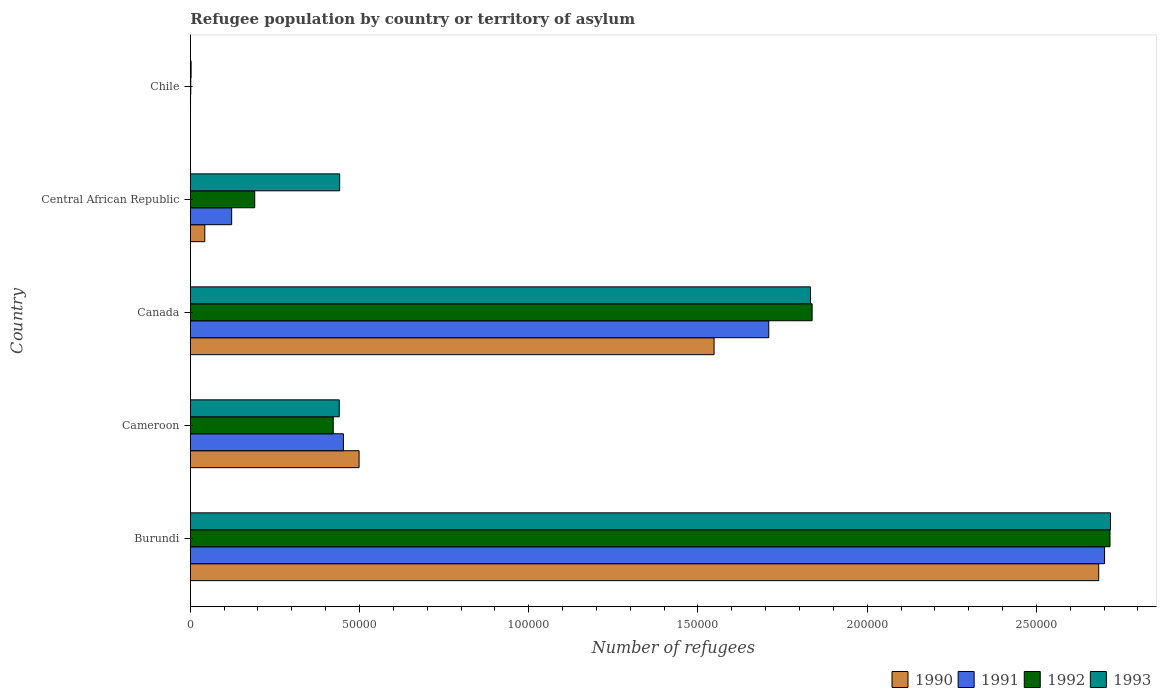How many groups of bars are there?
Give a very brief answer. 5. How many bars are there on the 4th tick from the bottom?
Your answer should be very brief. 4. What is the label of the 5th group of bars from the top?
Provide a short and direct response. Burundi. In how many cases, is the number of bars for a given country not equal to the number of legend labels?
Provide a succinct answer. 0. What is the number of refugees in 1993 in Burundi?
Provide a succinct answer. 2.72e+05. Across all countries, what is the maximum number of refugees in 1991?
Give a very brief answer. 2.70e+05. Across all countries, what is the minimum number of refugees in 1991?
Offer a terse response. 72. In which country was the number of refugees in 1993 maximum?
Provide a short and direct response. Burundi. In which country was the number of refugees in 1992 minimum?
Offer a terse response. Chile. What is the total number of refugees in 1991 in the graph?
Offer a very short reply. 4.99e+05. What is the difference between the number of refugees in 1990 in Cameroon and that in Canada?
Provide a short and direct response. -1.05e+05. What is the difference between the number of refugees in 1991 in Cameroon and the number of refugees in 1990 in Canada?
Offer a terse response. -1.10e+05. What is the average number of refugees in 1990 per country?
Offer a very short reply. 9.55e+04. What is the difference between the number of refugees in 1992 and number of refugees in 1991 in Central African Republic?
Your response must be concise. 6817. What is the ratio of the number of refugees in 1991 in Canada to that in Central African Republic?
Give a very brief answer. 13.98. What is the difference between the highest and the second highest number of refugees in 1991?
Offer a very short reply. 9.92e+04. What is the difference between the highest and the lowest number of refugees in 1991?
Provide a succinct answer. 2.70e+05. What does the 2nd bar from the top in Cameroon represents?
Your answer should be very brief. 1992. Is it the case that in every country, the sum of the number of refugees in 1991 and number of refugees in 1992 is greater than the number of refugees in 1993?
Your response must be concise. No. What is the difference between two consecutive major ticks on the X-axis?
Offer a terse response. 5.00e+04. Does the graph contain any zero values?
Your response must be concise. No. Where does the legend appear in the graph?
Offer a very short reply. Bottom right. How are the legend labels stacked?
Your answer should be very brief. Horizontal. What is the title of the graph?
Offer a very short reply. Refugee population by country or territory of asylum. Does "1961" appear as one of the legend labels in the graph?
Ensure brevity in your answer.  No. What is the label or title of the X-axis?
Provide a succinct answer. Number of refugees. What is the Number of refugees of 1990 in Burundi?
Ensure brevity in your answer.  2.68e+05. What is the Number of refugees of 1991 in Burundi?
Ensure brevity in your answer.  2.70e+05. What is the Number of refugees in 1992 in Burundi?
Your answer should be compact. 2.72e+05. What is the Number of refugees in 1993 in Burundi?
Offer a terse response. 2.72e+05. What is the Number of refugees in 1990 in Cameroon?
Provide a short and direct response. 4.99e+04. What is the Number of refugees in 1991 in Cameroon?
Offer a terse response. 4.52e+04. What is the Number of refugees in 1992 in Cameroon?
Ensure brevity in your answer.  4.22e+04. What is the Number of refugees in 1993 in Cameroon?
Give a very brief answer. 4.40e+04. What is the Number of refugees of 1990 in Canada?
Offer a terse response. 1.55e+05. What is the Number of refugees of 1991 in Canada?
Make the answer very short. 1.71e+05. What is the Number of refugees in 1992 in Canada?
Your answer should be compact. 1.84e+05. What is the Number of refugees of 1993 in Canada?
Your answer should be compact. 1.83e+05. What is the Number of refugees in 1990 in Central African Republic?
Give a very brief answer. 4284. What is the Number of refugees in 1991 in Central African Republic?
Offer a very short reply. 1.22e+04. What is the Number of refugees of 1992 in Central African Republic?
Your answer should be very brief. 1.90e+04. What is the Number of refugees of 1993 in Central African Republic?
Your answer should be very brief. 4.41e+04. What is the Number of refugees of 1992 in Chile?
Offer a very short reply. 142. What is the Number of refugees in 1993 in Chile?
Your answer should be compact. 239. Across all countries, what is the maximum Number of refugees in 1990?
Make the answer very short. 2.68e+05. Across all countries, what is the maximum Number of refugees in 1991?
Provide a short and direct response. 2.70e+05. Across all countries, what is the maximum Number of refugees of 1992?
Your answer should be very brief. 2.72e+05. Across all countries, what is the maximum Number of refugees in 1993?
Ensure brevity in your answer.  2.72e+05. Across all countries, what is the minimum Number of refugees in 1990?
Ensure brevity in your answer.  58. Across all countries, what is the minimum Number of refugees in 1991?
Your answer should be very brief. 72. Across all countries, what is the minimum Number of refugees of 1992?
Your response must be concise. 142. Across all countries, what is the minimum Number of refugees of 1993?
Your answer should be compact. 239. What is the total Number of refugees in 1990 in the graph?
Give a very brief answer. 4.77e+05. What is the total Number of refugees of 1991 in the graph?
Your response must be concise. 4.99e+05. What is the total Number of refugees of 1992 in the graph?
Make the answer very short. 5.17e+05. What is the total Number of refugees in 1993 in the graph?
Offer a terse response. 5.44e+05. What is the difference between the Number of refugees in 1990 in Burundi and that in Cameroon?
Ensure brevity in your answer.  2.19e+05. What is the difference between the Number of refugees in 1991 in Burundi and that in Cameroon?
Ensure brevity in your answer.  2.25e+05. What is the difference between the Number of refugees in 1992 in Burundi and that in Cameroon?
Offer a very short reply. 2.30e+05. What is the difference between the Number of refugees in 1993 in Burundi and that in Cameroon?
Offer a very short reply. 2.28e+05. What is the difference between the Number of refugees of 1990 in Burundi and that in Canada?
Your response must be concise. 1.14e+05. What is the difference between the Number of refugees in 1991 in Burundi and that in Canada?
Provide a short and direct response. 9.92e+04. What is the difference between the Number of refugees in 1992 in Burundi and that in Canada?
Offer a very short reply. 8.80e+04. What is the difference between the Number of refugees of 1993 in Burundi and that in Canada?
Your answer should be very brief. 8.86e+04. What is the difference between the Number of refugees in 1990 in Burundi and that in Central African Republic?
Provide a succinct answer. 2.64e+05. What is the difference between the Number of refugees of 1991 in Burundi and that in Central African Republic?
Your response must be concise. 2.58e+05. What is the difference between the Number of refugees of 1992 in Burundi and that in Central African Republic?
Your answer should be very brief. 2.53e+05. What is the difference between the Number of refugees of 1993 in Burundi and that in Central African Republic?
Keep it short and to the point. 2.28e+05. What is the difference between the Number of refugees of 1990 in Burundi and that in Chile?
Offer a terse response. 2.68e+05. What is the difference between the Number of refugees in 1991 in Burundi and that in Chile?
Provide a short and direct response. 2.70e+05. What is the difference between the Number of refugees in 1992 in Burundi and that in Chile?
Provide a succinct answer. 2.72e+05. What is the difference between the Number of refugees of 1993 in Burundi and that in Chile?
Give a very brief answer. 2.72e+05. What is the difference between the Number of refugees of 1990 in Cameroon and that in Canada?
Keep it short and to the point. -1.05e+05. What is the difference between the Number of refugees in 1991 in Cameroon and that in Canada?
Provide a short and direct response. -1.26e+05. What is the difference between the Number of refugees of 1992 in Cameroon and that in Canada?
Provide a succinct answer. -1.41e+05. What is the difference between the Number of refugees in 1993 in Cameroon and that in Canada?
Ensure brevity in your answer.  -1.39e+05. What is the difference between the Number of refugees of 1990 in Cameroon and that in Central African Republic?
Your answer should be very brief. 4.56e+04. What is the difference between the Number of refugees in 1991 in Cameroon and that in Central African Republic?
Your answer should be compact. 3.30e+04. What is the difference between the Number of refugees in 1992 in Cameroon and that in Central African Republic?
Provide a short and direct response. 2.32e+04. What is the difference between the Number of refugees of 1993 in Cameroon and that in Central African Republic?
Make the answer very short. -116. What is the difference between the Number of refugees of 1990 in Cameroon and that in Chile?
Your response must be concise. 4.98e+04. What is the difference between the Number of refugees of 1991 in Cameroon and that in Chile?
Your answer should be very brief. 4.52e+04. What is the difference between the Number of refugees in 1992 in Cameroon and that in Chile?
Keep it short and to the point. 4.21e+04. What is the difference between the Number of refugees of 1993 in Cameroon and that in Chile?
Your answer should be compact. 4.38e+04. What is the difference between the Number of refugees of 1990 in Canada and that in Central African Republic?
Offer a very short reply. 1.50e+05. What is the difference between the Number of refugees in 1991 in Canada and that in Central African Republic?
Make the answer very short. 1.59e+05. What is the difference between the Number of refugees in 1992 in Canada and that in Central African Republic?
Give a very brief answer. 1.65e+05. What is the difference between the Number of refugees in 1993 in Canada and that in Central African Republic?
Make the answer very short. 1.39e+05. What is the difference between the Number of refugees of 1990 in Canada and that in Chile?
Your answer should be very brief. 1.55e+05. What is the difference between the Number of refugees of 1991 in Canada and that in Chile?
Your response must be concise. 1.71e+05. What is the difference between the Number of refugees in 1992 in Canada and that in Chile?
Offer a very short reply. 1.84e+05. What is the difference between the Number of refugees in 1993 in Canada and that in Chile?
Your answer should be very brief. 1.83e+05. What is the difference between the Number of refugees of 1990 in Central African Republic and that in Chile?
Your answer should be very brief. 4226. What is the difference between the Number of refugees in 1991 in Central African Republic and that in Chile?
Offer a very short reply. 1.22e+04. What is the difference between the Number of refugees of 1992 in Central African Republic and that in Chile?
Give a very brief answer. 1.89e+04. What is the difference between the Number of refugees in 1993 in Central African Republic and that in Chile?
Ensure brevity in your answer.  4.39e+04. What is the difference between the Number of refugees of 1990 in Burundi and the Number of refugees of 1991 in Cameroon?
Ensure brevity in your answer.  2.23e+05. What is the difference between the Number of refugees of 1990 in Burundi and the Number of refugees of 1992 in Cameroon?
Offer a very short reply. 2.26e+05. What is the difference between the Number of refugees of 1990 in Burundi and the Number of refugees of 1993 in Cameroon?
Your answer should be very brief. 2.24e+05. What is the difference between the Number of refugees of 1991 in Burundi and the Number of refugees of 1992 in Cameroon?
Make the answer very short. 2.28e+05. What is the difference between the Number of refugees of 1991 in Burundi and the Number of refugees of 1993 in Cameroon?
Offer a terse response. 2.26e+05. What is the difference between the Number of refugees of 1992 in Burundi and the Number of refugees of 1993 in Cameroon?
Offer a very short reply. 2.28e+05. What is the difference between the Number of refugees in 1990 in Burundi and the Number of refugees in 1991 in Canada?
Offer a very short reply. 9.75e+04. What is the difference between the Number of refugees in 1990 in Burundi and the Number of refugees in 1992 in Canada?
Provide a succinct answer. 8.47e+04. What is the difference between the Number of refugees of 1990 in Burundi and the Number of refugees of 1993 in Canada?
Keep it short and to the point. 8.52e+04. What is the difference between the Number of refugees in 1991 in Burundi and the Number of refugees in 1992 in Canada?
Your answer should be compact. 8.64e+04. What is the difference between the Number of refugees in 1991 in Burundi and the Number of refugees in 1993 in Canada?
Offer a terse response. 8.69e+04. What is the difference between the Number of refugees in 1992 in Burundi and the Number of refugees in 1993 in Canada?
Keep it short and to the point. 8.85e+04. What is the difference between the Number of refugees in 1990 in Burundi and the Number of refugees in 1991 in Central African Republic?
Your answer should be very brief. 2.56e+05. What is the difference between the Number of refugees of 1990 in Burundi and the Number of refugees of 1992 in Central African Republic?
Your answer should be compact. 2.49e+05. What is the difference between the Number of refugees in 1990 in Burundi and the Number of refugees in 1993 in Central African Republic?
Offer a very short reply. 2.24e+05. What is the difference between the Number of refugees of 1991 in Burundi and the Number of refugees of 1992 in Central African Republic?
Make the answer very short. 2.51e+05. What is the difference between the Number of refugees in 1991 in Burundi and the Number of refugees in 1993 in Central African Republic?
Provide a short and direct response. 2.26e+05. What is the difference between the Number of refugees of 1992 in Burundi and the Number of refugees of 1993 in Central African Republic?
Your answer should be compact. 2.28e+05. What is the difference between the Number of refugees of 1990 in Burundi and the Number of refugees of 1991 in Chile?
Offer a very short reply. 2.68e+05. What is the difference between the Number of refugees in 1990 in Burundi and the Number of refugees in 1992 in Chile?
Make the answer very short. 2.68e+05. What is the difference between the Number of refugees in 1990 in Burundi and the Number of refugees in 1993 in Chile?
Your answer should be very brief. 2.68e+05. What is the difference between the Number of refugees in 1991 in Burundi and the Number of refugees in 1992 in Chile?
Ensure brevity in your answer.  2.70e+05. What is the difference between the Number of refugees in 1991 in Burundi and the Number of refugees in 1993 in Chile?
Make the answer very short. 2.70e+05. What is the difference between the Number of refugees of 1992 in Burundi and the Number of refugees of 1993 in Chile?
Make the answer very short. 2.72e+05. What is the difference between the Number of refugees in 1990 in Cameroon and the Number of refugees in 1991 in Canada?
Make the answer very short. -1.21e+05. What is the difference between the Number of refugees in 1990 in Cameroon and the Number of refugees in 1992 in Canada?
Provide a short and direct response. -1.34e+05. What is the difference between the Number of refugees in 1990 in Cameroon and the Number of refugees in 1993 in Canada?
Offer a terse response. -1.33e+05. What is the difference between the Number of refugees in 1991 in Cameroon and the Number of refugees in 1992 in Canada?
Your response must be concise. -1.38e+05. What is the difference between the Number of refugees of 1991 in Cameroon and the Number of refugees of 1993 in Canada?
Provide a short and direct response. -1.38e+05. What is the difference between the Number of refugees of 1992 in Cameroon and the Number of refugees of 1993 in Canada?
Ensure brevity in your answer.  -1.41e+05. What is the difference between the Number of refugees in 1990 in Cameroon and the Number of refugees in 1991 in Central African Republic?
Your response must be concise. 3.77e+04. What is the difference between the Number of refugees in 1990 in Cameroon and the Number of refugees in 1992 in Central African Republic?
Make the answer very short. 3.08e+04. What is the difference between the Number of refugees of 1990 in Cameroon and the Number of refugees of 1993 in Central African Republic?
Provide a short and direct response. 5747. What is the difference between the Number of refugees in 1991 in Cameroon and the Number of refugees in 1992 in Central African Republic?
Your answer should be compact. 2.62e+04. What is the difference between the Number of refugees in 1991 in Cameroon and the Number of refugees in 1993 in Central African Republic?
Your answer should be compact. 1108. What is the difference between the Number of refugees of 1992 in Cameroon and the Number of refugees of 1993 in Central African Republic?
Your response must be concise. -1896. What is the difference between the Number of refugees of 1990 in Cameroon and the Number of refugees of 1991 in Chile?
Offer a very short reply. 4.98e+04. What is the difference between the Number of refugees of 1990 in Cameroon and the Number of refugees of 1992 in Chile?
Your response must be concise. 4.97e+04. What is the difference between the Number of refugees in 1990 in Cameroon and the Number of refugees in 1993 in Chile?
Offer a very short reply. 4.96e+04. What is the difference between the Number of refugees of 1991 in Cameroon and the Number of refugees of 1992 in Chile?
Offer a terse response. 4.51e+04. What is the difference between the Number of refugees of 1991 in Cameroon and the Number of refugees of 1993 in Chile?
Keep it short and to the point. 4.50e+04. What is the difference between the Number of refugees in 1992 in Cameroon and the Number of refugees in 1993 in Chile?
Offer a very short reply. 4.20e+04. What is the difference between the Number of refugees in 1990 in Canada and the Number of refugees in 1991 in Central African Republic?
Offer a very short reply. 1.43e+05. What is the difference between the Number of refugees in 1990 in Canada and the Number of refugees in 1992 in Central African Republic?
Provide a short and direct response. 1.36e+05. What is the difference between the Number of refugees in 1990 in Canada and the Number of refugees in 1993 in Central African Republic?
Give a very brief answer. 1.11e+05. What is the difference between the Number of refugees of 1991 in Canada and the Number of refugees of 1992 in Central African Republic?
Ensure brevity in your answer.  1.52e+05. What is the difference between the Number of refugees in 1991 in Canada and the Number of refugees in 1993 in Central African Republic?
Your answer should be very brief. 1.27e+05. What is the difference between the Number of refugees of 1992 in Canada and the Number of refugees of 1993 in Central African Republic?
Keep it short and to the point. 1.40e+05. What is the difference between the Number of refugees of 1990 in Canada and the Number of refugees of 1991 in Chile?
Offer a very short reply. 1.55e+05. What is the difference between the Number of refugees in 1990 in Canada and the Number of refugees in 1992 in Chile?
Give a very brief answer. 1.55e+05. What is the difference between the Number of refugees in 1990 in Canada and the Number of refugees in 1993 in Chile?
Your answer should be compact. 1.55e+05. What is the difference between the Number of refugees of 1991 in Canada and the Number of refugees of 1992 in Chile?
Offer a terse response. 1.71e+05. What is the difference between the Number of refugees in 1991 in Canada and the Number of refugees in 1993 in Chile?
Give a very brief answer. 1.71e+05. What is the difference between the Number of refugees in 1992 in Canada and the Number of refugees in 1993 in Chile?
Your response must be concise. 1.83e+05. What is the difference between the Number of refugees in 1990 in Central African Republic and the Number of refugees in 1991 in Chile?
Provide a short and direct response. 4212. What is the difference between the Number of refugees of 1990 in Central African Republic and the Number of refugees of 1992 in Chile?
Ensure brevity in your answer.  4142. What is the difference between the Number of refugees of 1990 in Central African Republic and the Number of refugees of 1993 in Chile?
Your answer should be compact. 4045. What is the difference between the Number of refugees in 1991 in Central African Republic and the Number of refugees in 1992 in Chile?
Your answer should be very brief. 1.21e+04. What is the difference between the Number of refugees in 1991 in Central African Republic and the Number of refugees in 1993 in Chile?
Provide a short and direct response. 1.20e+04. What is the difference between the Number of refugees in 1992 in Central African Republic and the Number of refugees in 1993 in Chile?
Provide a succinct answer. 1.88e+04. What is the average Number of refugees in 1990 per country?
Offer a terse response. 9.55e+04. What is the average Number of refugees of 1991 per country?
Your response must be concise. 9.97e+04. What is the average Number of refugees of 1992 per country?
Make the answer very short. 1.03e+05. What is the average Number of refugees of 1993 per country?
Your response must be concise. 1.09e+05. What is the difference between the Number of refugees of 1990 and Number of refugees of 1991 in Burundi?
Provide a succinct answer. -1733. What is the difference between the Number of refugees in 1990 and Number of refugees in 1992 in Burundi?
Give a very brief answer. -3342. What is the difference between the Number of refugees of 1990 and Number of refugees of 1993 in Burundi?
Provide a succinct answer. -3480. What is the difference between the Number of refugees in 1991 and Number of refugees in 1992 in Burundi?
Provide a succinct answer. -1609. What is the difference between the Number of refugees of 1991 and Number of refugees of 1993 in Burundi?
Your answer should be compact. -1747. What is the difference between the Number of refugees of 1992 and Number of refugees of 1993 in Burundi?
Provide a short and direct response. -138. What is the difference between the Number of refugees of 1990 and Number of refugees of 1991 in Cameroon?
Make the answer very short. 4639. What is the difference between the Number of refugees of 1990 and Number of refugees of 1992 in Cameroon?
Your answer should be very brief. 7643. What is the difference between the Number of refugees in 1990 and Number of refugees in 1993 in Cameroon?
Offer a terse response. 5863. What is the difference between the Number of refugees of 1991 and Number of refugees of 1992 in Cameroon?
Your answer should be very brief. 3004. What is the difference between the Number of refugees in 1991 and Number of refugees in 1993 in Cameroon?
Offer a terse response. 1224. What is the difference between the Number of refugees in 1992 and Number of refugees in 1993 in Cameroon?
Offer a very short reply. -1780. What is the difference between the Number of refugees of 1990 and Number of refugees of 1991 in Canada?
Provide a short and direct response. -1.62e+04. What is the difference between the Number of refugees of 1990 and Number of refugees of 1992 in Canada?
Keep it short and to the point. -2.90e+04. What is the difference between the Number of refugees of 1990 and Number of refugees of 1993 in Canada?
Your response must be concise. -2.85e+04. What is the difference between the Number of refugees in 1991 and Number of refugees in 1992 in Canada?
Your answer should be very brief. -1.28e+04. What is the difference between the Number of refugees of 1991 and Number of refugees of 1993 in Canada?
Offer a terse response. -1.23e+04. What is the difference between the Number of refugees in 1992 and Number of refugees in 1993 in Canada?
Offer a very short reply. 482. What is the difference between the Number of refugees of 1990 and Number of refugees of 1991 in Central African Republic?
Give a very brief answer. -7939. What is the difference between the Number of refugees of 1990 and Number of refugees of 1992 in Central African Republic?
Make the answer very short. -1.48e+04. What is the difference between the Number of refugees in 1990 and Number of refugees in 1993 in Central African Republic?
Provide a succinct answer. -3.98e+04. What is the difference between the Number of refugees in 1991 and Number of refugees in 1992 in Central African Republic?
Keep it short and to the point. -6817. What is the difference between the Number of refugees in 1991 and Number of refugees in 1993 in Central African Republic?
Give a very brief answer. -3.19e+04. What is the difference between the Number of refugees of 1992 and Number of refugees of 1993 in Central African Republic?
Make the answer very short. -2.51e+04. What is the difference between the Number of refugees of 1990 and Number of refugees of 1991 in Chile?
Keep it short and to the point. -14. What is the difference between the Number of refugees in 1990 and Number of refugees in 1992 in Chile?
Keep it short and to the point. -84. What is the difference between the Number of refugees of 1990 and Number of refugees of 1993 in Chile?
Offer a very short reply. -181. What is the difference between the Number of refugees of 1991 and Number of refugees of 1992 in Chile?
Offer a very short reply. -70. What is the difference between the Number of refugees of 1991 and Number of refugees of 1993 in Chile?
Provide a succinct answer. -167. What is the difference between the Number of refugees in 1992 and Number of refugees in 1993 in Chile?
Offer a terse response. -97. What is the ratio of the Number of refugees of 1990 in Burundi to that in Cameroon?
Make the answer very short. 5.38. What is the ratio of the Number of refugees of 1991 in Burundi to that in Cameroon?
Your answer should be compact. 5.97. What is the ratio of the Number of refugees of 1992 in Burundi to that in Cameroon?
Offer a terse response. 6.43. What is the ratio of the Number of refugees of 1993 in Burundi to that in Cameroon?
Keep it short and to the point. 6.18. What is the ratio of the Number of refugees of 1990 in Burundi to that in Canada?
Offer a terse response. 1.73. What is the ratio of the Number of refugees in 1991 in Burundi to that in Canada?
Provide a succinct answer. 1.58. What is the ratio of the Number of refugees in 1992 in Burundi to that in Canada?
Provide a succinct answer. 1.48. What is the ratio of the Number of refugees in 1993 in Burundi to that in Canada?
Provide a short and direct response. 1.48. What is the ratio of the Number of refugees of 1990 in Burundi to that in Central African Republic?
Ensure brevity in your answer.  62.65. What is the ratio of the Number of refugees of 1991 in Burundi to that in Central African Republic?
Provide a short and direct response. 22.1. What is the ratio of the Number of refugees of 1992 in Burundi to that in Central African Republic?
Your answer should be compact. 14.27. What is the ratio of the Number of refugees in 1993 in Burundi to that in Central African Republic?
Offer a terse response. 6.16. What is the ratio of the Number of refugees in 1990 in Burundi to that in Chile?
Your response must be concise. 4627.64. What is the ratio of the Number of refugees of 1991 in Burundi to that in Chile?
Offer a very short reply. 3751.89. What is the ratio of the Number of refugees of 1992 in Burundi to that in Chile?
Your response must be concise. 1913.7. What is the ratio of the Number of refugees of 1993 in Burundi to that in Chile?
Provide a short and direct response. 1137.59. What is the ratio of the Number of refugees in 1990 in Cameroon to that in Canada?
Your response must be concise. 0.32. What is the ratio of the Number of refugees of 1991 in Cameroon to that in Canada?
Offer a terse response. 0.26. What is the ratio of the Number of refugees in 1992 in Cameroon to that in Canada?
Make the answer very short. 0.23. What is the ratio of the Number of refugees of 1993 in Cameroon to that in Canada?
Offer a very short reply. 0.24. What is the ratio of the Number of refugees in 1990 in Cameroon to that in Central African Republic?
Your response must be concise. 11.64. What is the ratio of the Number of refugees in 1991 in Cameroon to that in Central African Republic?
Your response must be concise. 3.7. What is the ratio of the Number of refugees in 1992 in Cameroon to that in Central African Republic?
Your response must be concise. 2.22. What is the ratio of the Number of refugees of 1990 in Cameroon to that in Chile?
Your answer should be compact. 859.93. What is the ratio of the Number of refugees of 1991 in Cameroon to that in Chile?
Offer a terse response. 628.29. What is the ratio of the Number of refugees in 1992 in Cameroon to that in Chile?
Keep it short and to the point. 297.42. What is the ratio of the Number of refugees of 1993 in Cameroon to that in Chile?
Give a very brief answer. 184.15. What is the ratio of the Number of refugees of 1990 in Canada to that in Central African Republic?
Provide a succinct answer. 36.13. What is the ratio of the Number of refugees in 1991 in Canada to that in Central African Republic?
Offer a terse response. 13.98. What is the ratio of the Number of refugees of 1992 in Canada to that in Central African Republic?
Your answer should be compact. 9.65. What is the ratio of the Number of refugees of 1993 in Canada to that in Central African Republic?
Make the answer very short. 4.15. What is the ratio of the Number of refugees in 1990 in Canada to that in Chile?
Your answer should be compact. 2668.29. What is the ratio of the Number of refugees in 1991 in Canada to that in Chile?
Provide a short and direct response. 2373.83. What is the ratio of the Number of refugees of 1992 in Canada to that in Chile?
Ensure brevity in your answer.  1293.82. What is the ratio of the Number of refugees in 1993 in Canada to that in Chile?
Offer a terse response. 766.7. What is the ratio of the Number of refugees of 1990 in Central African Republic to that in Chile?
Your answer should be compact. 73.86. What is the ratio of the Number of refugees of 1991 in Central African Republic to that in Chile?
Provide a succinct answer. 169.76. What is the ratio of the Number of refugees in 1992 in Central African Republic to that in Chile?
Ensure brevity in your answer.  134.08. What is the ratio of the Number of refugees of 1993 in Central African Republic to that in Chile?
Your response must be concise. 184.64. What is the difference between the highest and the second highest Number of refugees of 1990?
Give a very brief answer. 1.14e+05. What is the difference between the highest and the second highest Number of refugees of 1991?
Your response must be concise. 9.92e+04. What is the difference between the highest and the second highest Number of refugees of 1992?
Give a very brief answer. 8.80e+04. What is the difference between the highest and the second highest Number of refugees of 1993?
Your answer should be very brief. 8.86e+04. What is the difference between the highest and the lowest Number of refugees in 1990?
Provide a short and direct response. 2.68e+05. What is the difference between the highest and the lowest Number of refugees of 1991?
Your response must be concise. 2.70e+05. What is the difference between the highest and the lowest Number of refugees of 1992?
Offer a terse response. 2.72e+05. What is the difference between the highest and the lowest Number of refugees in 1993?
Offer a terse response. 2.72e+05. 